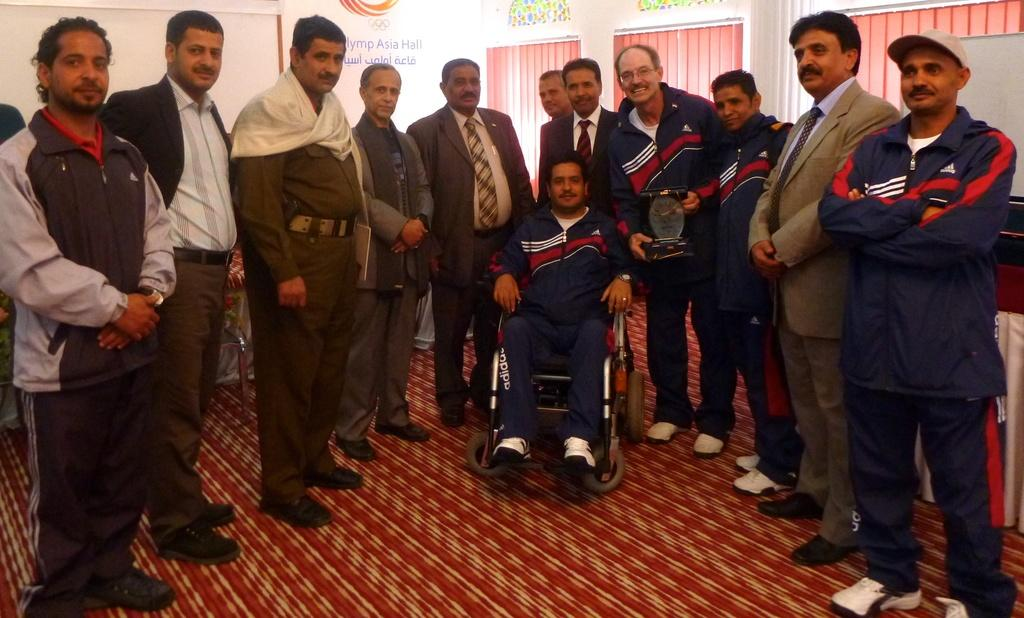What is happening in the image? There are persons standing in the image. What are the persons wearing? The persons are wearing clothes. Can you describe the person in a different position? There is a person sitting on a wheelchair in the image. What type of cheese is being served on the table in the image? There is no table or cheese present in the image. How long has the person been resting in the wheelchair in the image? The image does not provide information about the person's rest or duration of time spent in the wheelchair. 